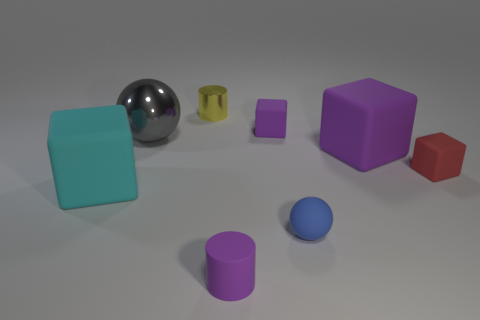Subtract all tiny red blocks. How many blocks are left? 3 Subtract all cyan cylinders. How many purple blocks are left? 2 Subtract all red cubes. How many cubes are left? 3 Add 1 big yellow metal spheres. How many objects exist? 9 Subtract all red cubes. Subtract all green balls. How many cubes are left? 3 Subtract all spheres. How many objects are left? 6 Add 2 tiny spheres. How many tiny spheres are left? 3 Add 2 yellow rubber cubes. How many yellow rubber cubes exist? 2 Subtract 0 blue cubes. How many objects are left? 8 Subtract all purple matte cubes. Subtract all blue balls. How many objects are left? 5 